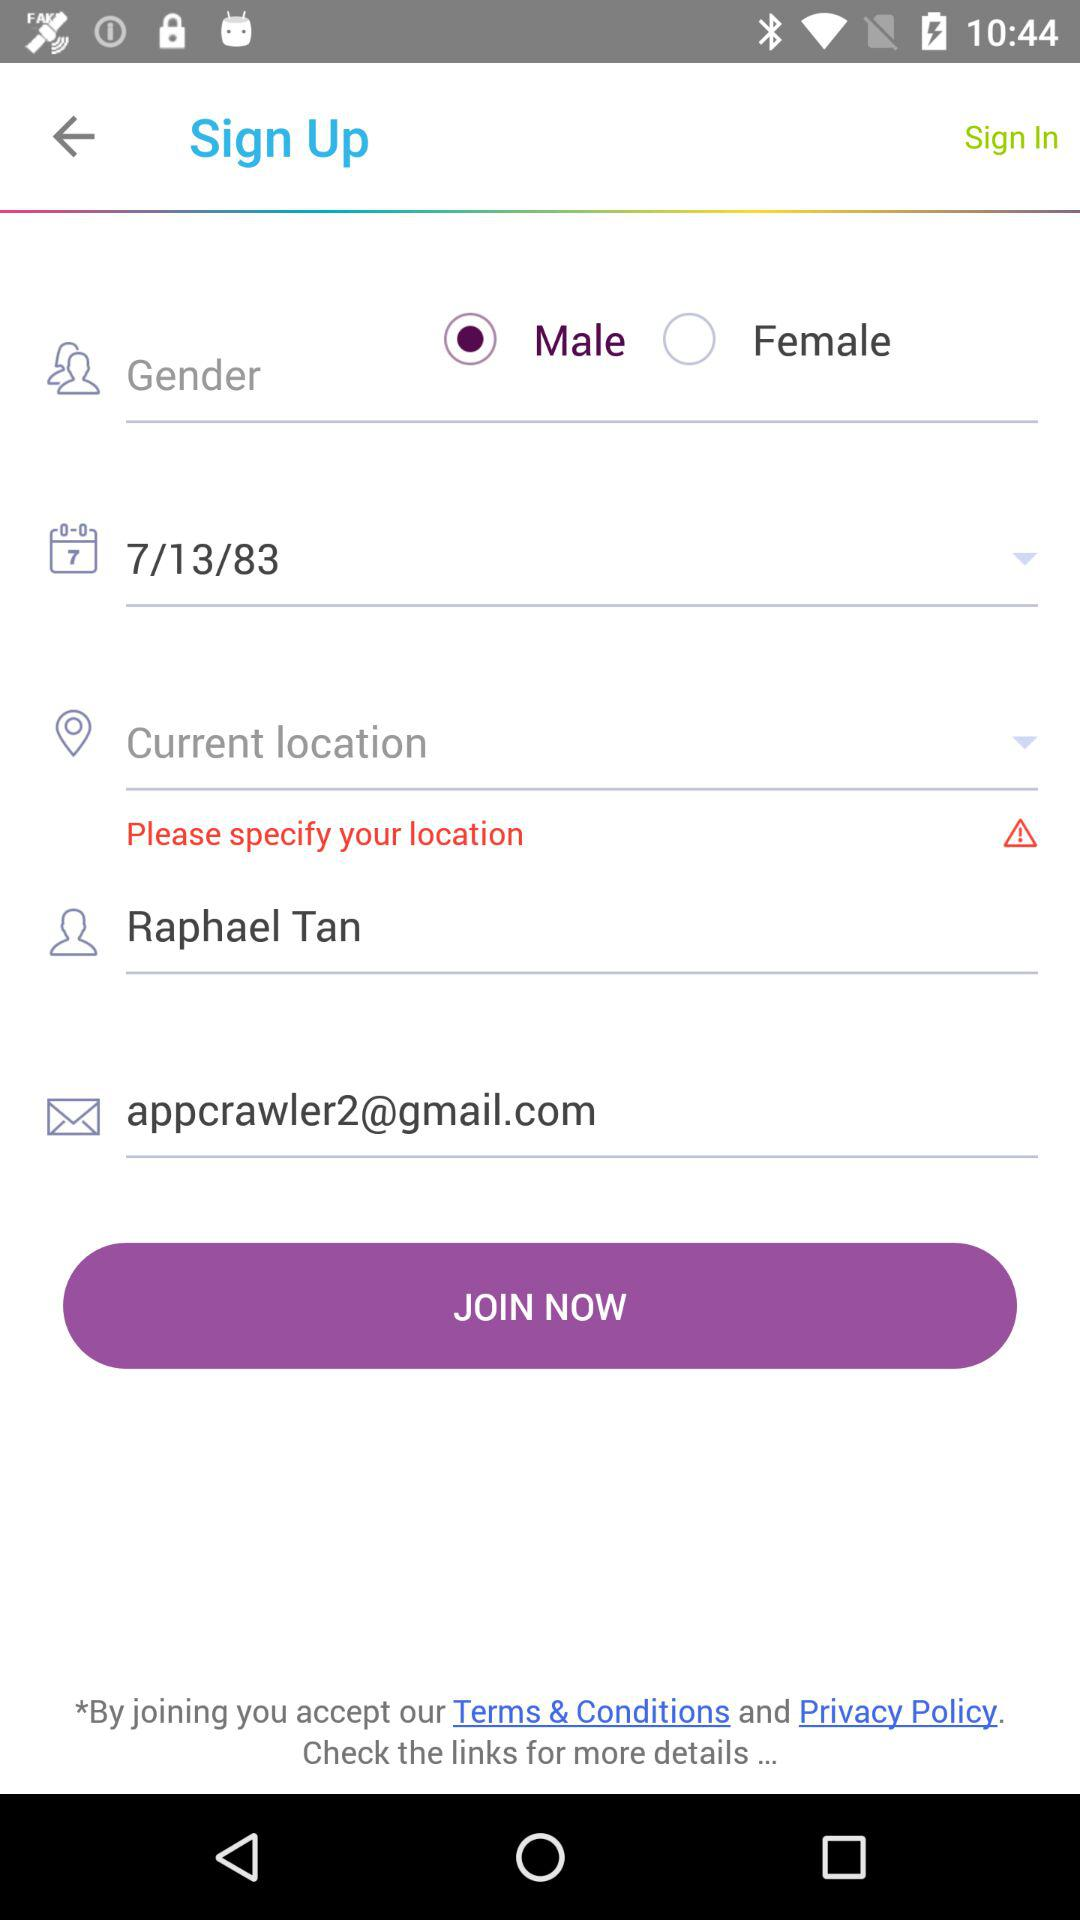What is the gender of the user? The gender of the user is male. 